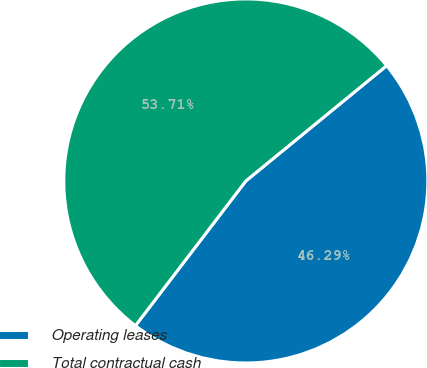<chart> <loc_0><loc_0><loc_500><loc_500><pie_chart><fcel>Operating leases<fcel>Total contractual cash<nl><fcel>46.29%<fcel>53.71%<nl></chart> 